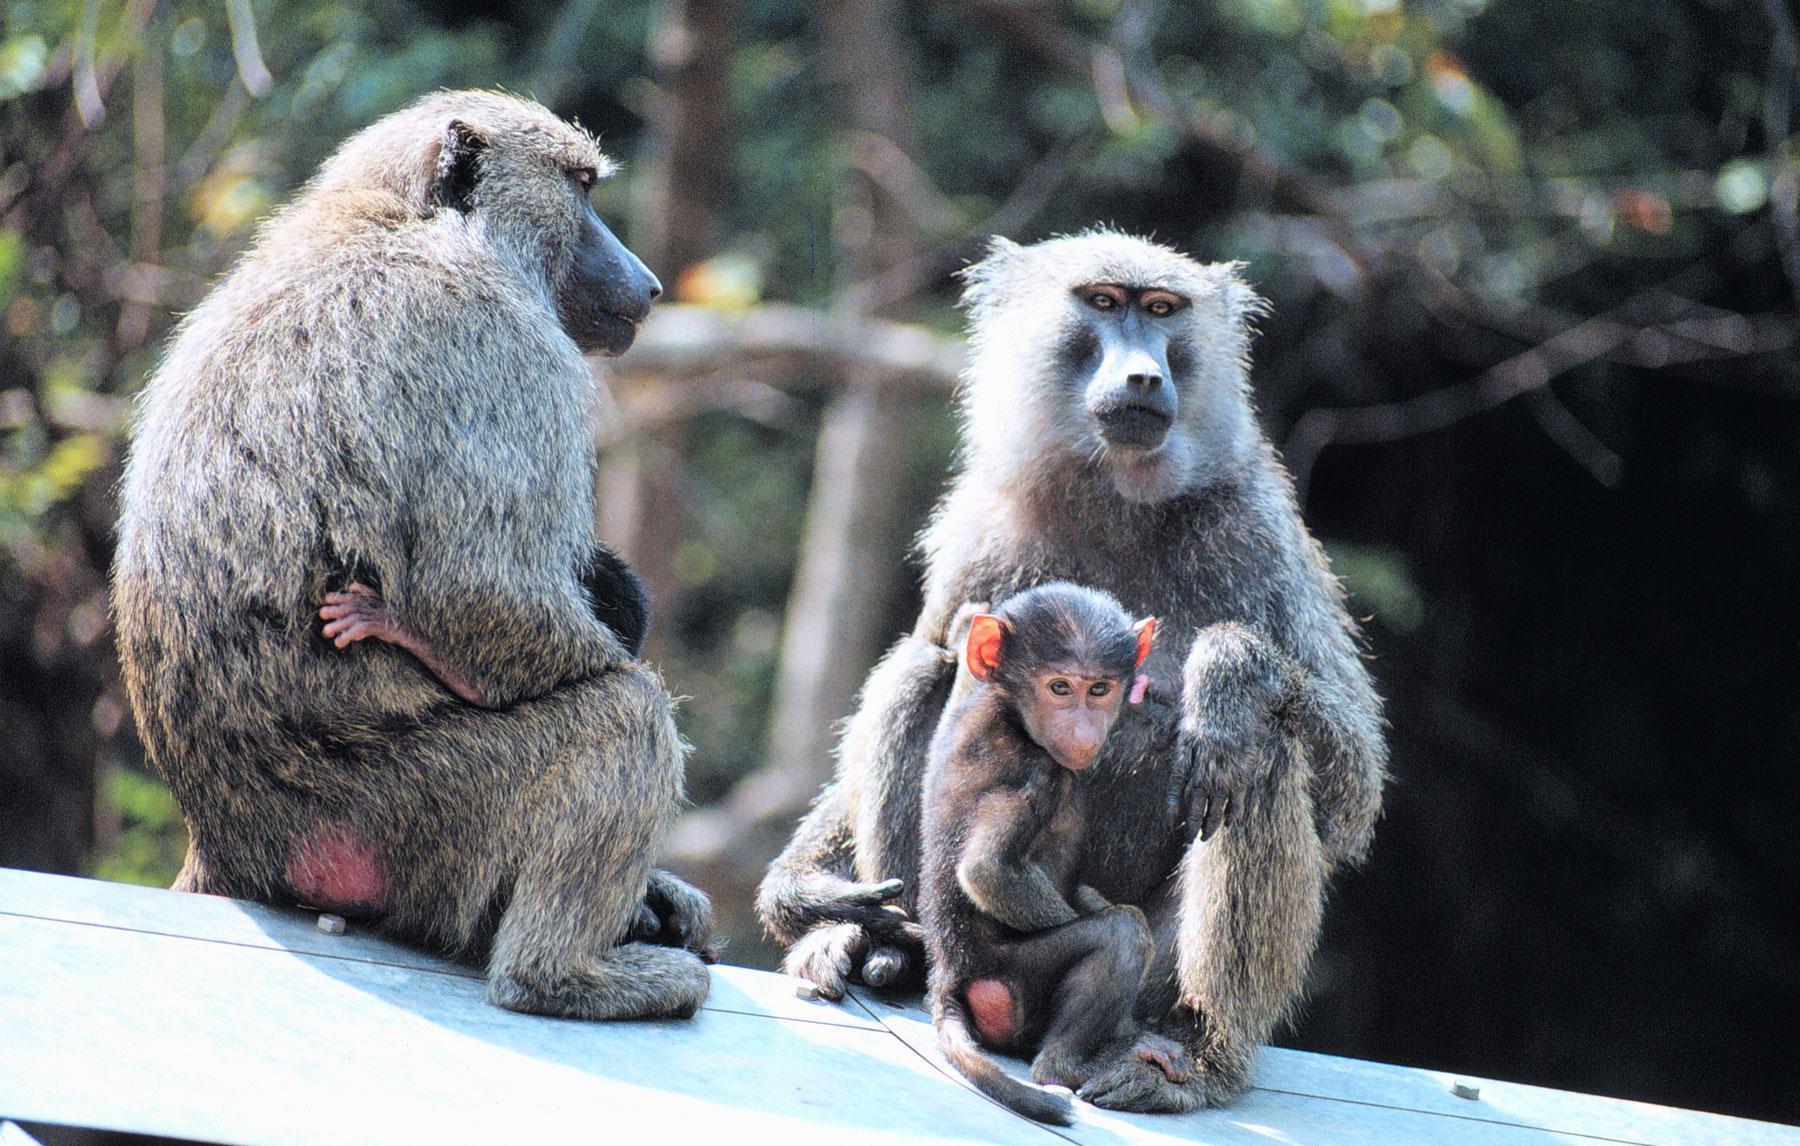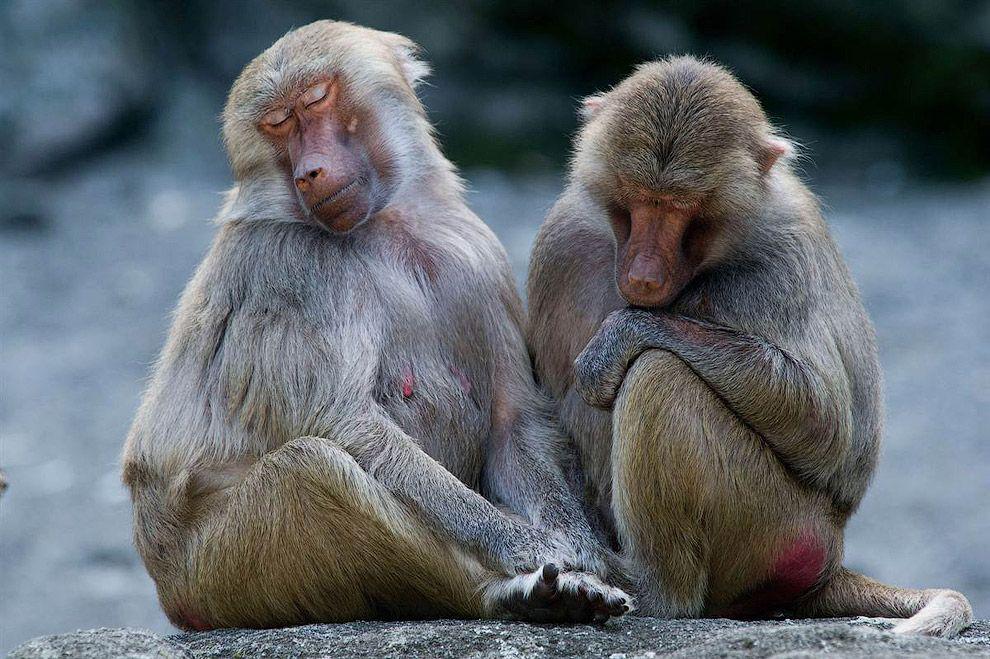The first image is the image on the left, the second image is the image on the right. For the images displayed, is the sentence "There are at least three animals in the image on the left." factually correct? Answer yes or no. Yes. The first image is the image on the left, the second image is the image on the right. Considering the images on both sides, is "There is no more than two baboons in the left image." valid? Answer yes or no. No. 